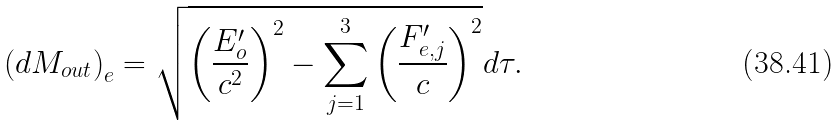<formula> <loc_0><loc_0><loc_500><loc_500>\left ( d M _ { o u t } \right ) _ { e } = \sqrt { \left ( \frac { E ^ { \prime } _ { o } } { c ^ { 2 } } \right ) ^ { 2 } - \sum _ { j = 1 } ^ { 3 } \left ( \frac { F ^ { \prime } _ { e , j } } { c } \right ) ^ { 2 } } d \tau .</formula> 